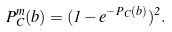Convert formula to latex. <formula><loc_0><loc_0><loc_500><loc_500>P ^ { m } _ { C } ( b ) = ( 1 - e ^ { - P _ { C } ( b ) } ) ^ { 2 } .</formula> 